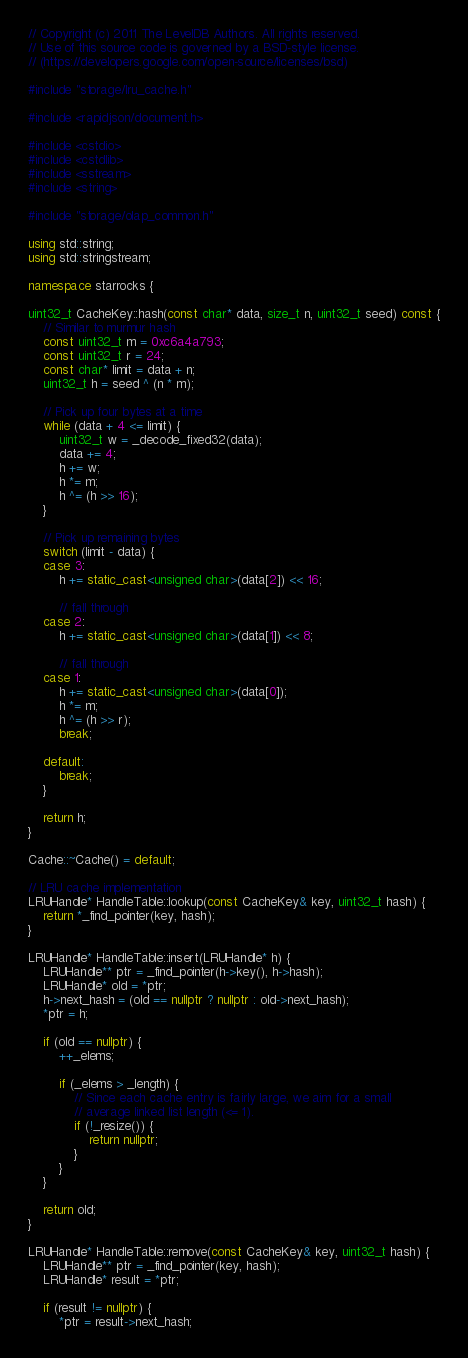<code> <loc_0><loc_0><loc_500><loc_500><_C++_>// Copyright (c) 2011 The LevelDB Authors. All rights reserved.
// Use of this source code is governed by a BSD-style license.
// (https://developers.google.com/open-source/licenses/bsd)

#include "storage/lru_cache.h"

#include <rapidjson/document.h>

#include <cstdio>
#include <cstdlib>
#include <sstream>
#include <string>

#include "storage/olap_common.h"

using std::string;
using std::stringstream;

namespace starrocks {

uint32_t CacheKey::hash(const char* data, size_t n, uint32_t seed) const {
    // Similar to murmur hash
    const uint32_t m = 0xc6a4a793;
    const uint32_t r = 24;
    const char* limit = data + n;
    uint32_t h = seed ^ (n * m);

    // Pick up four bytes at a time
    while (data + 4 <= limit) {
        uint32_t w = _decode_fixed32(data);
        data += 4;
        h += w;
        h *= m;
        h ^= (h >> 16);
    }

    // Pick up remaining bytes
    switch (limit - data) {
    case 3:
        h += static_cast<unsigned char>(data[2]) << 16;

        // fall through
    case 2:
        h += static_cast<unsigned char>(data[1]) << 8;

        // fall through
    case 1:
        h += static_cast<unsigned char>(data[0]);
        h *= m;
        h ^= (h >> r);
        break;

    default:
        break;
    }

    return h;
}

Cache::~Cache() = default;

// LRU cache implementation
LRUHandle* HandleTable::lookup(const CacheKey& key, uint32_t hash) {
    return *_find_pointer(key, hash);
}

LRUHandle* HandleTable::insert(LRUHandle* h) {
    LRUHandle** ptr = _find_pointer(h->key(), h->hash);
    LRUHandle* old = *ptr;
    h->next_hash = (old == nullptr ? nullptr : old->next_hash);
    *ptr = h;

    if (old == nullptr) {
        ++_elems;

        if (_elems > _length) {
            // Since each cache entry is fairly large, we aim for a small
            // average linked list length (<= 1).
            if (!_resize()) {
                return nullptr;
            }
        }
    }

    return old;
}

LRUHandle* HandleTable::remove(const CacheKey& key, uint32_t hash) {
    LRUHandle** ptr = _find_pointer(key, hash);
    LRUHandle* result = *ptr;

    if (result != nullptr) {
        *ptr = result->next_hash;</code> 